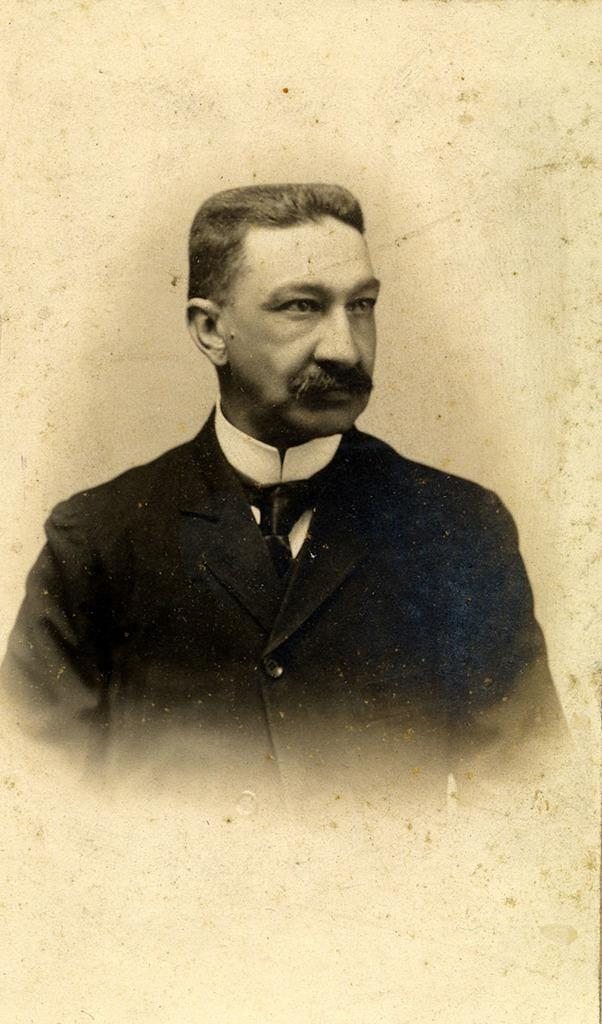What is the main subject of the image? There is a person in the image. Can you describe the background of the image? There is a colored background in the image. What type of form is the person holding in the image? There is no form visible in the image. What type of waste is present in the image? There is no waste present in the image. What type of vessel is the person using in the image? There is no vessel present in the image. 